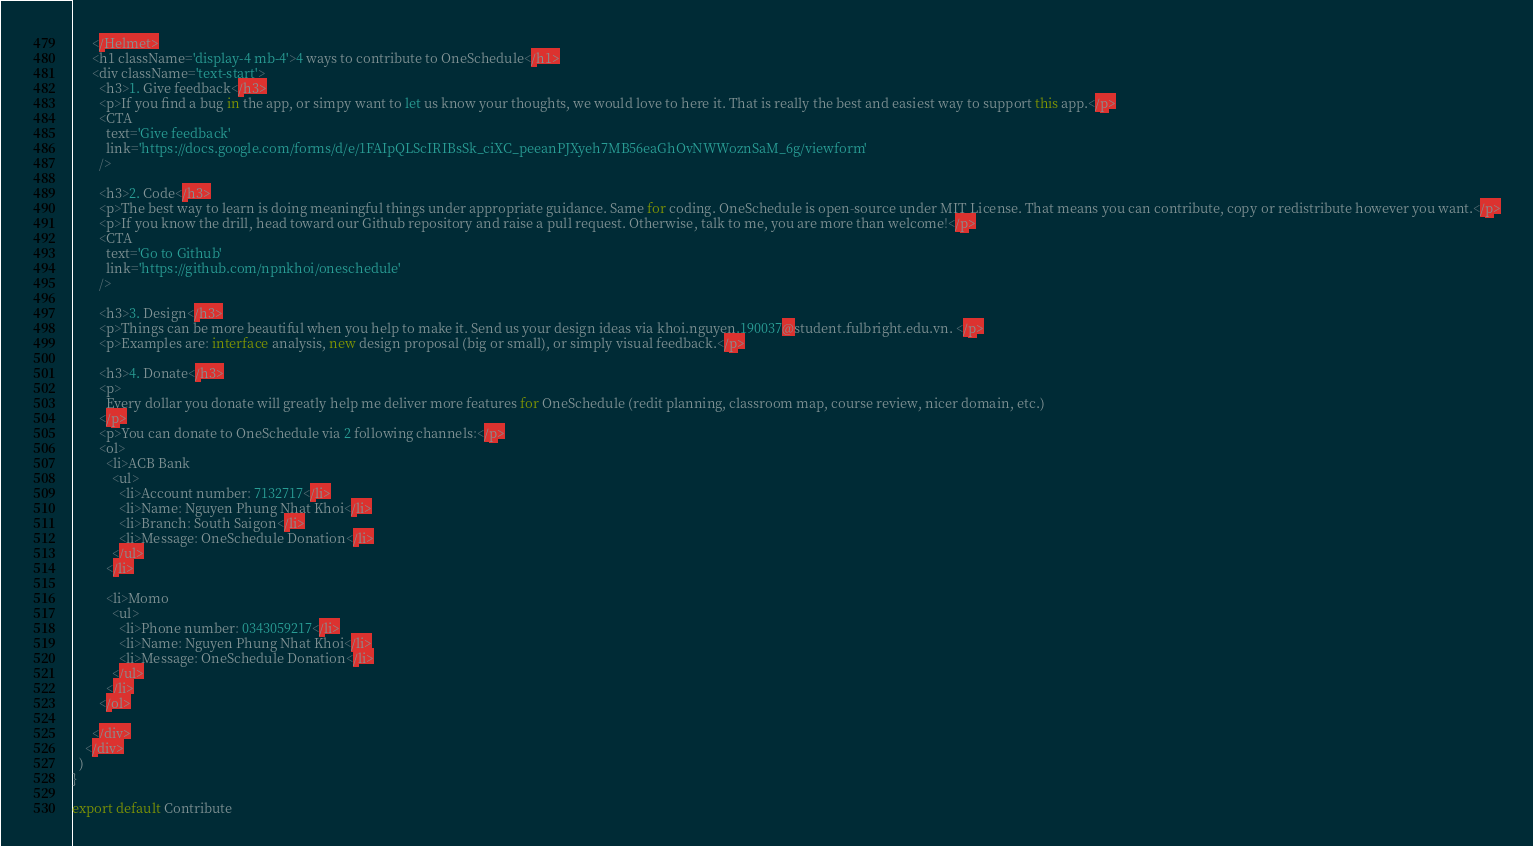<code> <loc_0><loc_0><loc_500><loc_500><_JavaScript_>      </Helmet>
      <h1 className='display-4 mb-4'>4 ways to contribute to OneSchedule</h1>
      <div className='text-start'>
        <h3>1. Give feedback</h3>
        <p>If you find a bug in the app, or simpy want to let us know your thoughts, we would love to here it. That is really the best and easiest way to support this app.</p>
        <CTA 
          text='Give feedback'
          link='https://docs.google.com/forms/d/e/1FAIpQLScIRIBsSk_ciXC_peeanPJXyeh7MB56eaGhOvNWWoznSaM_6g/viewform'
        />

        <h3>2. Code</h3>
        <p>The best way to learn is doing meaningful things under appropriate guidance. Same for coding. OneSchedule is open-source under MIT License. That means you can contribute, copy or redistribute however you want.</p>
        <p>If you know the drill, head toward our Github repository and raise a pull request. Otherwise, talk to me, you are more than welcome!</p>
        <CTA 
          text='Go to Github'
          link='https://github.com/npnkhoi/oneschedule'
        />

        <h3>3. Design</h3>
        <p>Things can be more beautiful when you help to make it. Send us your design ideas via khoi.nguyen.190037@student.fulbright.edu.vn. </p>
        <p>Examples are: interface analysis, new design proposal (big or small), or simply visual feedback.</p>

        <h3>4. Donate</h3>
        <p>
          Every dollar you donate will greatly help me deliver more features for OneSchedule (redit planning, classroom map, course review, nicer domain, etc.)
        </p>
        <p>You can donate to OneSchedule via 2 following channels:</p>
        <ol>
          <li>ACB Bank
            <ul>
              <li>Account number: 7132717</li>
              <li>Name: Nguyen Phung Nhat Khoi</li>
              <li>Branch: South Saigon</li>
              <li>Message: OneSchedule Donation</li>
            </ul>
          </li>

          <li>Momo
            <ul>
              <li>Phone number: 0343059217</li>
              <li>Name: Nguyen Phung Nhat Khoi</li>
              <li>Message: OneSchedule Donation</li>
            </ul>
          </li>
        </ol>

      </div>
    </div>
  )
}

export default Contribute
</code> 